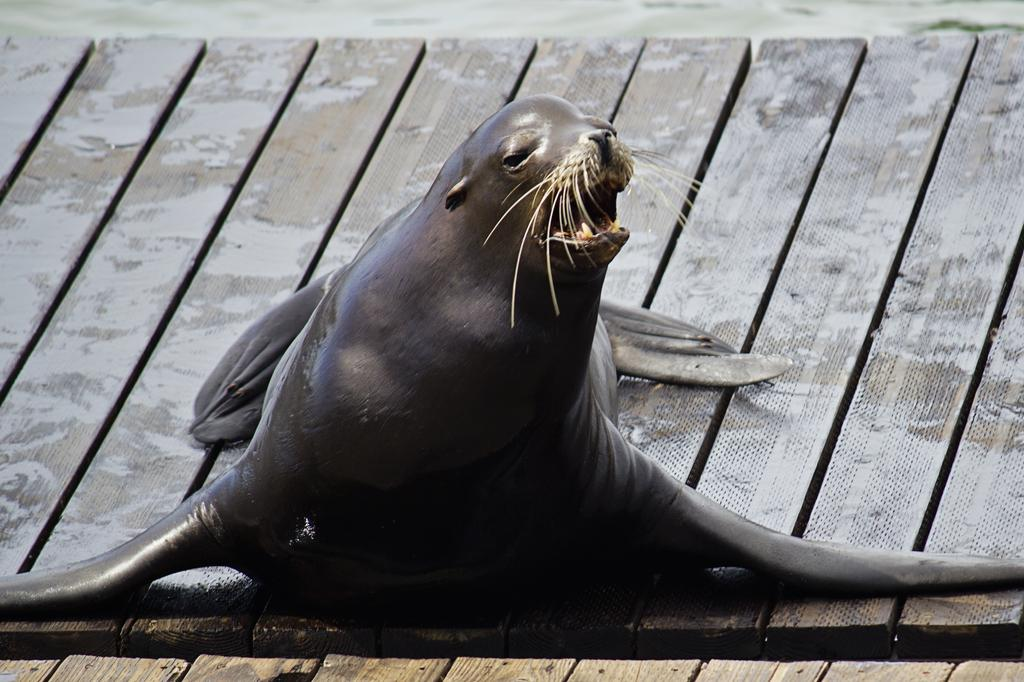What type of creature is present in the image? There is an animal in the image. Can you describe the animal's surroundings? The animal is on wooden planks. What type of mask is the animal wearing in the image? There is no mask present in the image; the animal is simply on wooden planks. 